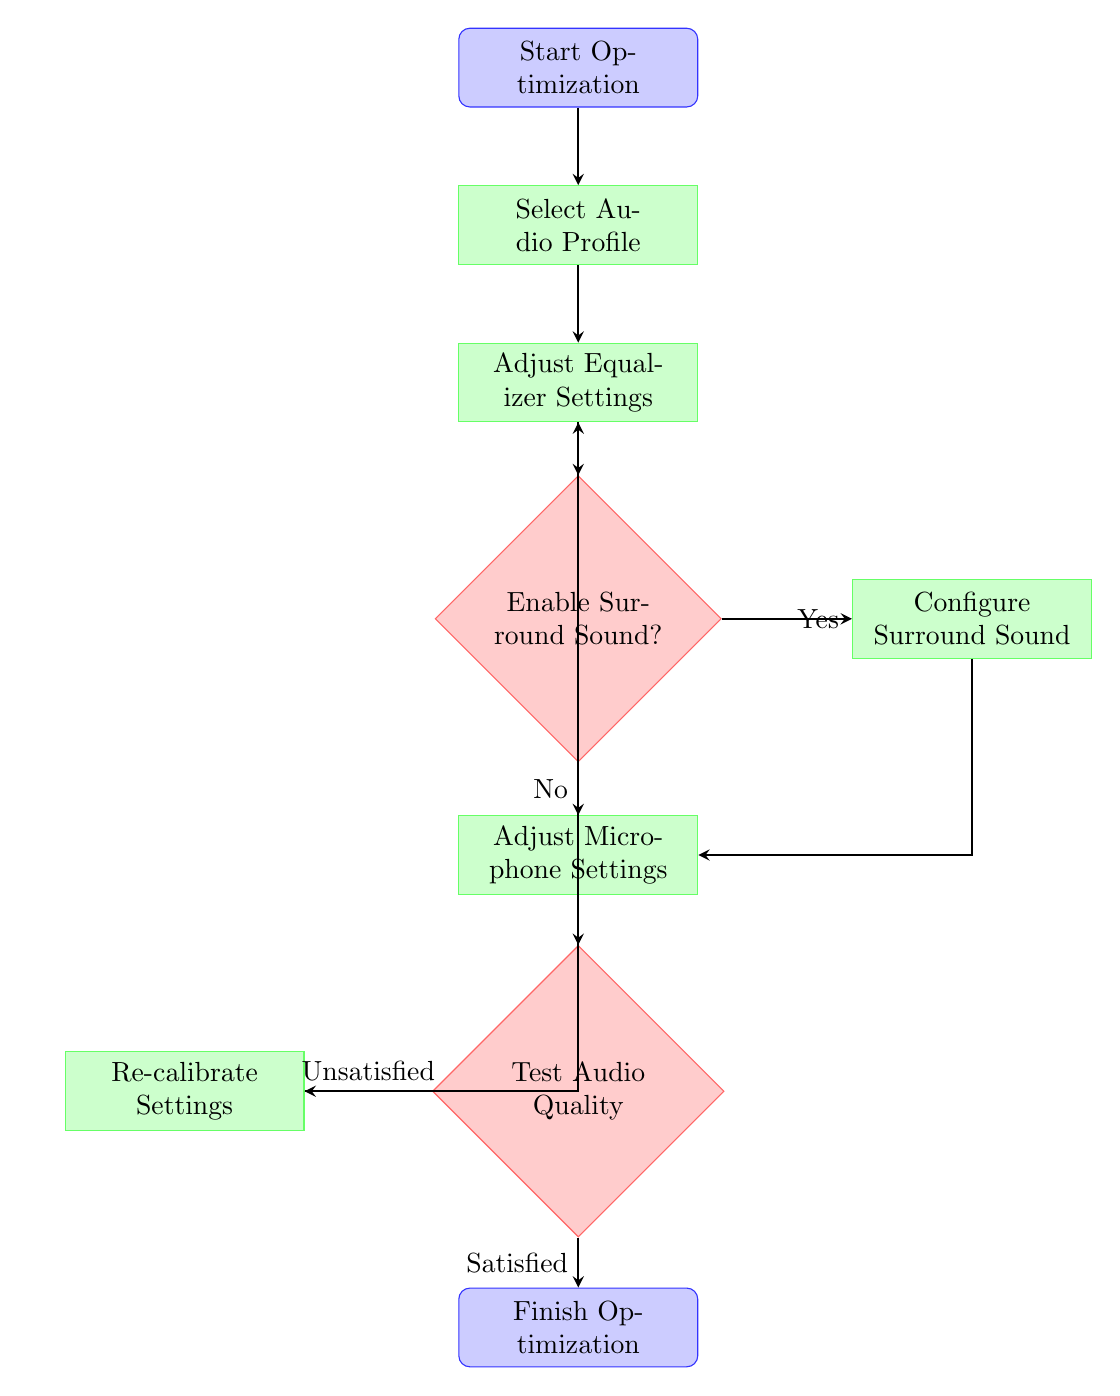What is the first step in the optimization process? The first step is represented by the node labeled "Start Optimization," indicating that the process of optimizing audio settings begins here.
Answer: Start Optimization How many process nodes are in the diagram? The process nodes in the diagram are "Select Audio Profile", "Adjust Equalizer Settings", "Configure Surround Sound", "Adjust Microphone Settings", and "Re-calibrate Settings". Counting these gives us a total of four process nodes.
Answer: Four Which decision node follows the "Adjust Equalizer Settings" node? After "Adjust Equalizer Settings," the next node is a decision node labeled "Enable Surround Sound?", which requires a choice regarding enabling surround sound features.
Answer: Enable Surround Sound? What happens if the answer to "Enable Surround Sound?" is yes? If the answer is yes, the flow proceeds to the node labeled "Configure Surround Sound," indicating that the user should set up surround sound configurations.
Answer: Configure Surround Sound What do you do if the audio quality is "Unsatisfied"? If the audio quality is deemed "Unsatisfied" during testing, the flow directs the user to "Re-calibrate Settings," allowing adjustments to be made based on feedback.
Answer: Re-calibrate Settings How many edges connect the "Test Audio Quality" node? The "Test Audio Quality" node has two edges connecting to it, one leading to "Satisfied" and the other to "Unsatisfied," representing the possible outcomes of the audio test.
Answer: Two In which step do you adjust microphone settings? The step to adjust microphone settings occurs directly after the "Enable Surround Sound?" decision, whether surround sound is enabled or not, making it the next sequential action.
Answer: Adjust Microphone Settings What is the final output of the optimization process? The final output is signified by the node labeled "Finish Optimization," which indicates the conclusion of the audio settings optimization process.
Answer: Finish Optimization 